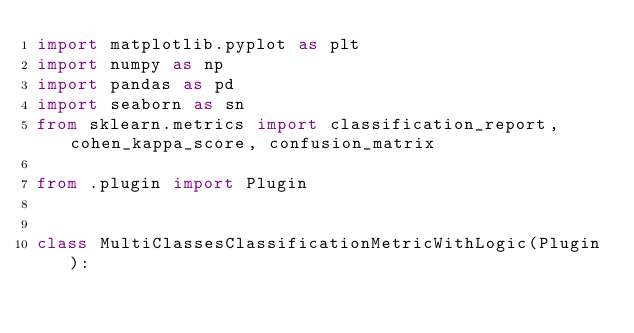Convert code to text. <code><loc_0><loc_0><loc_500><loc_500><_Python_>import matplotlib.pyplot as plt
import numpy as np
import pandas as pd
import seaborn as sn
from sklearn.metrics import classification_report, cohen_kappa_score, confusion_matrix

from .plugin import Plugin


class MultiClassesClassificationMetricWithLogic(Plugin):</code> 